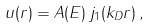<formula> <loc_0><loc_0><loc_500><loc_500>u ( r ) = A ( E ) \, j _ { 1 } ( k _ { D } r ) \, ,</formula> 